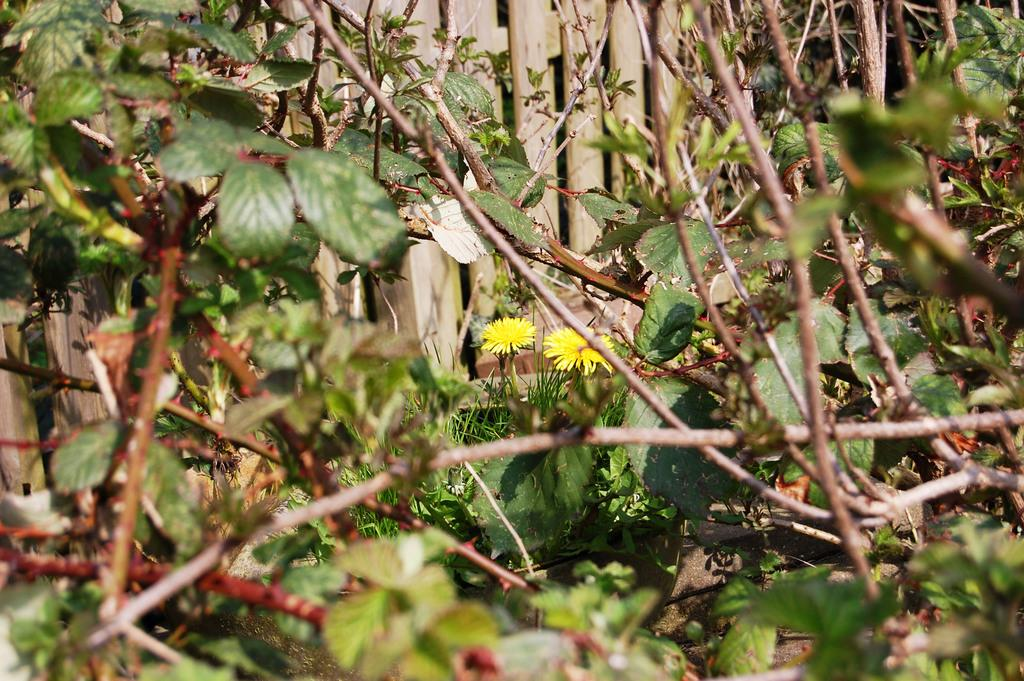What type of living organisms can be seen in the image? Plants, leaves, and flowers are visible in the image. Can you describe the plants in the image? The plants have leaves and flowers. What is visible in the background of the image? There is fencing in the background of the image. What type of needle can be seen in the image? There is no needle present in the image. What discovery was made by the crowd in the image? There is no crowd present in the image, and therefore no discovery can be observed. 